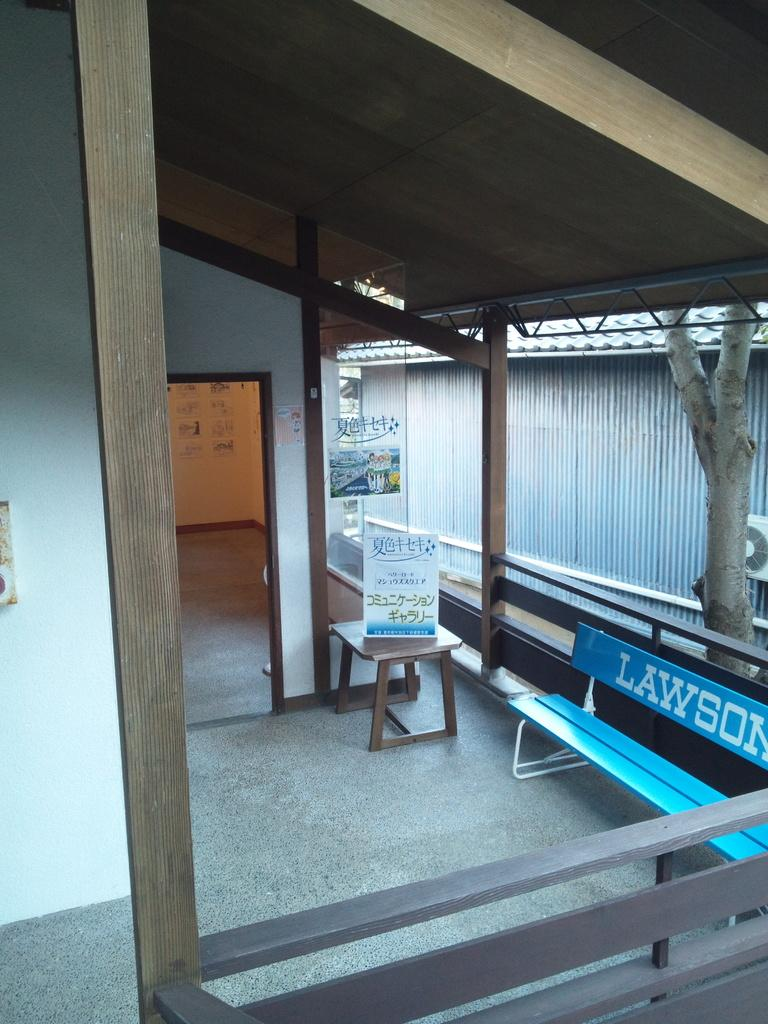<image>
Give a short and clear explanation of the subsequent image. Area with a seat that says Lawson on it next to a table with a sign. 